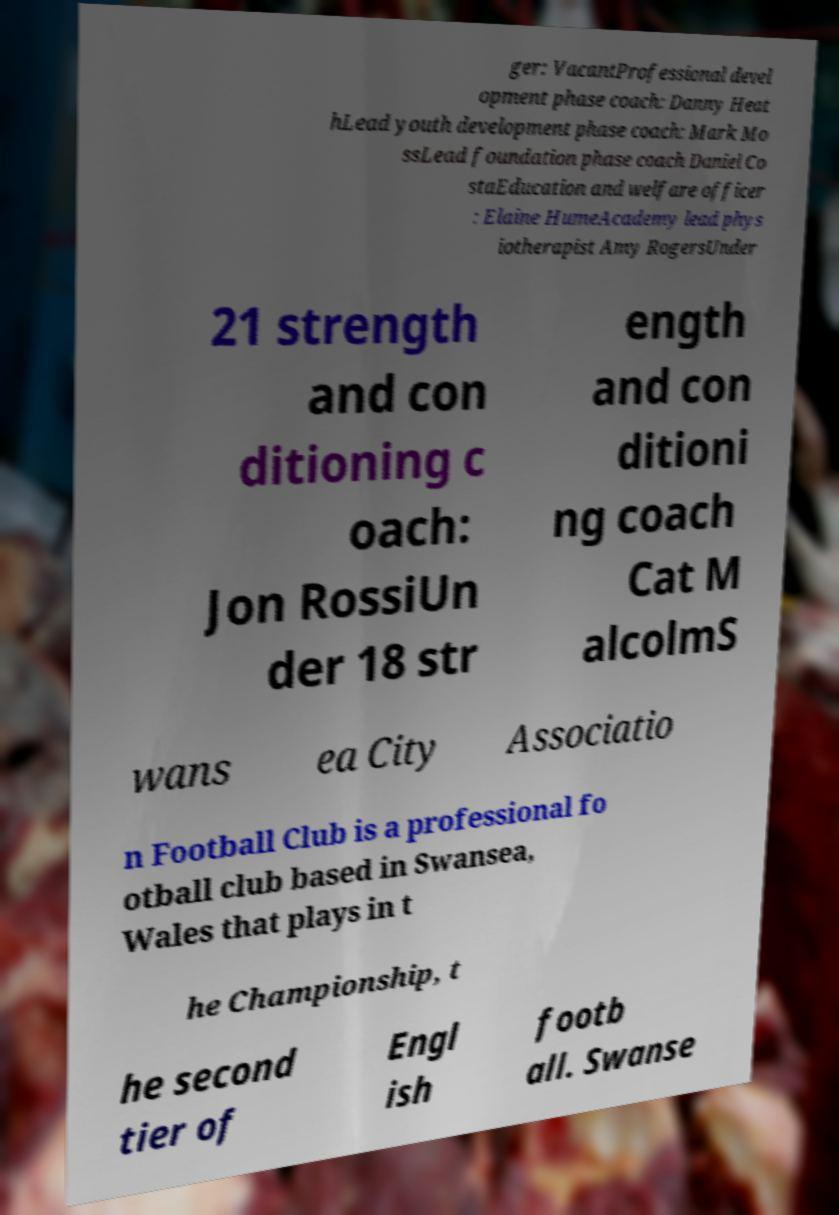Can you read and provide the text displayed in the image?This photo seems to have some interesting text. Can you extract and type it out for me? ger: VacantProfessional devel opment phase coach: Danny Heat hLead youth development phase coach: Mark Mo ssLead foundation phase coach Daniel Co staEducation and welfare officer : Elaine HumeAcademy lead phys iotherapist Amy RogersUnder 21 strength and con ditioning c oach: Jon RossiUn der 18 str ength and con ditioni ng coach Cat M alcolmS wans ea City Associatio n Football Club is a professional fo otball club based in Swansea, Wales that plays in t he Championship, t he second tier of Engl ish footb all. Swanse 